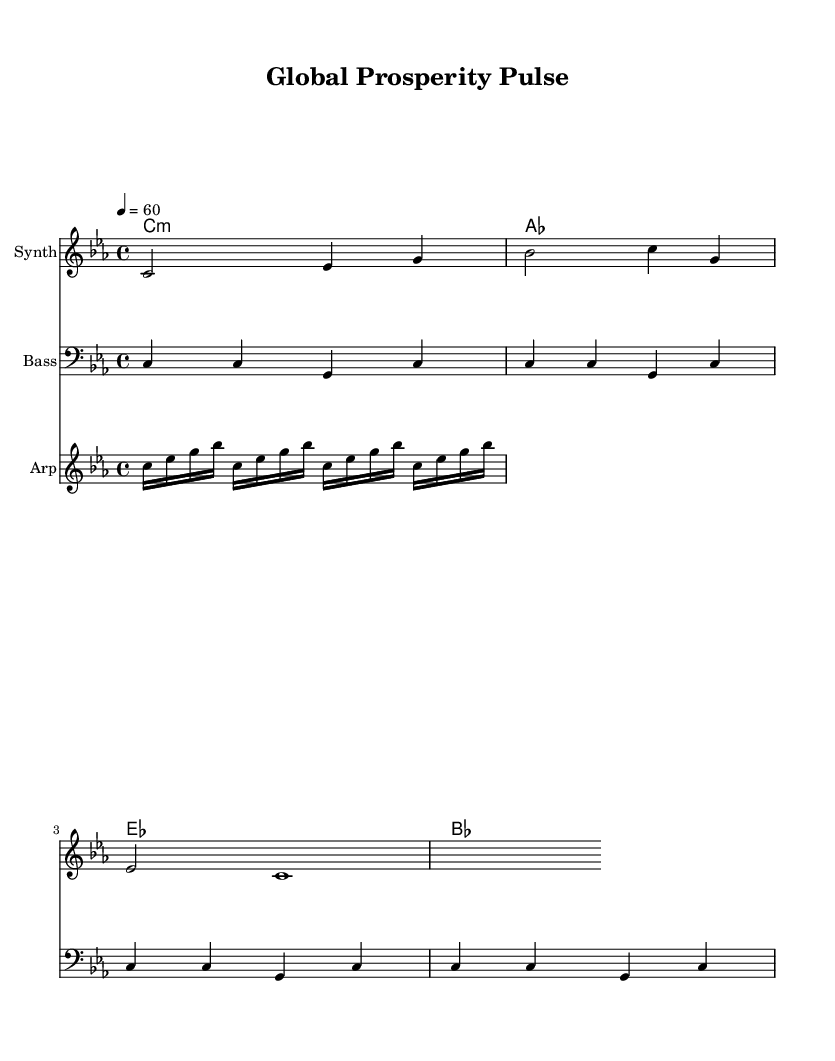What is the key signature of this music? The key signature is C minor, which has three flats (B♭, E♭, and A♭). This can be identified by looking at the key indicated at the beginning of the score.
Answer: C minor What is the time signature of this piece? The time signature is 4/4, which can be seen at the beginning of the score. This means there are four beats per measure, and the quarter note gets one beat.
Answer: 4/4 What is the tempo marking for this composition? The tempo marking indicates a pace of 60 beats per minute, which is noted as "4 = 60" at the beginning of the score. This means the quarter note is played at a speed of 60 beats each minute.
Answer: 60 How many measures are there in the melody? The melody consists of three measures, which can be counted by identifying the vertical bar lines in the staff. Each measure is separated by a bar line.
Answer: 3 What is the harmonic progression in this piece? The harmonic progression follows a pattern of C minor, A♭, E♭, and B♭ chords, which can be determined by analyzing the chords listed in the chord staff.
Answer: C minor, A♭, E♭, B♭ What is the instrument used for the melody in this score? The melody is assigned to the instrument labeled as "Synth," which is mentioned in the staff title. This indicates the sound and texture of the melodic line is synthesized electronic music.
Answer: Synth How is the bass line structured in this piece? The bass line is structured in a consistent pattern of quarter notes alternating between C and G, as seen in the bass staff. This steady pattern supports the harmonic foundation of the piece.
Answer: Steady quarter notes 